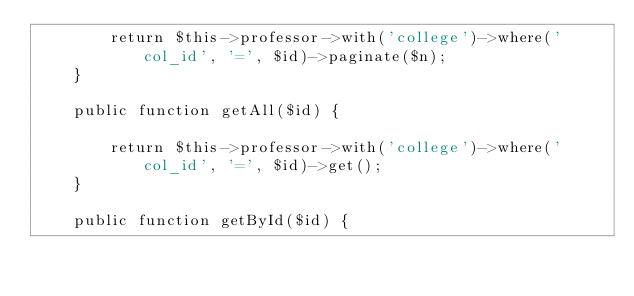Convert code to text. <code><loc_0><loc_0><loc_500><loc_500><_PHP_>        return $this->professor->with('college')->where('col_id', '=', $id)->paginate($n);
    }
    
    public function getAll($id) {

        return $this->professor->with('college')->where('col_id', '=', $id)->get();
    }

    public function getById($id) {</code> 